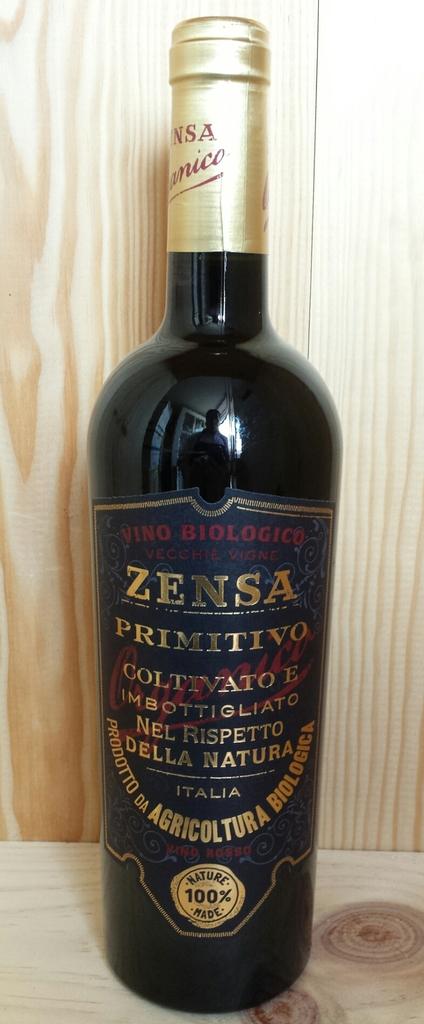What brand of wine is this?
Provide a succinct answer. Zensa. 